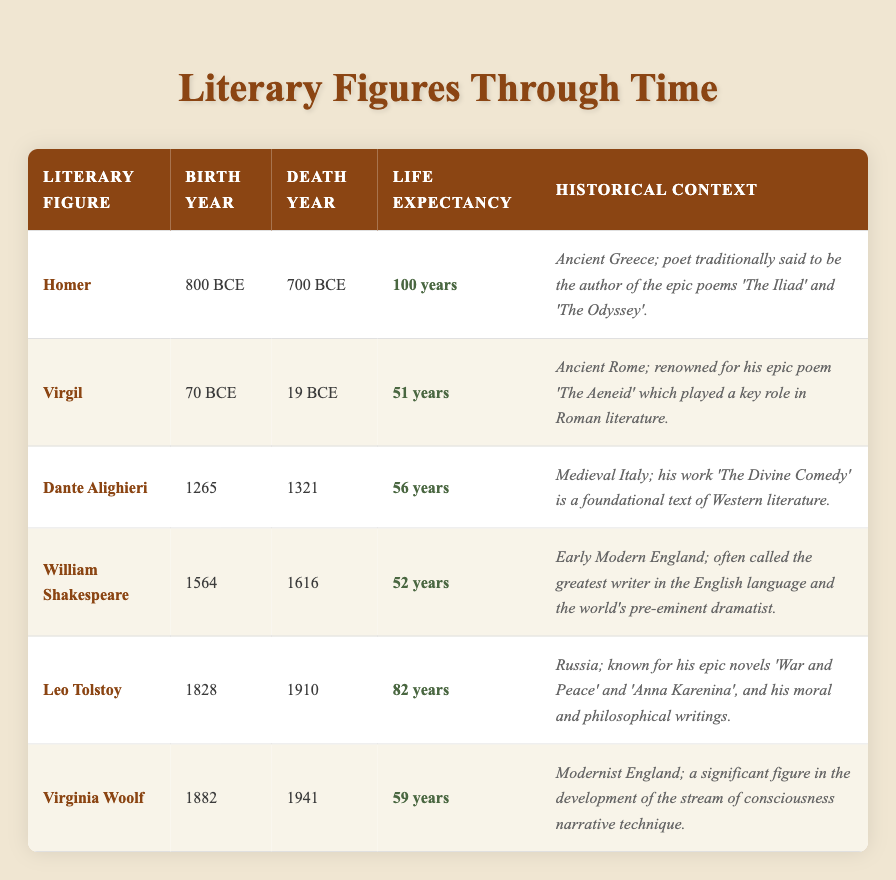What is the life expectancy of Leo Tolstoy? From the table, the life expectancy of Leo Tolstoy is clearly listed as 82 years.
Answer: 82 years Who lived the longest among these literary figures? By comparing the life expectancies, Leo Tolstoy has the highest life expectancy at 82 years, making him the longest-living literary figure in the table.
Answer: Leo Tolstoy How many years did William Shakespeare live? According to the table, William Shakespeare's life expectancy is recorded as 52 years.
Answer: 52 years Is it true that Virginia Woolf lived longer than Dante Alighieri? By examining the life expectancies in the table, Virginia Woolf lived for 59 years, while Dante Alighieri lived for 56 years, which confirms that Woolf lived longer.
Answer: Yes What is the average life expectancy of the literary figures listed? To find the average life expectancy, sum the individual life expectancies: (100 + 51 + 56 + 52 + 82 + 59) = 400. Then, divide by the total number of figures, which is 6. Thus, the average life expectancy is 400 / 6 = approximately 66.67 years.
Answer: 66.67 years Which historical context corresponds to the author of 'The Aeneid'? From the table, Virgil, known for 'The Aeneid', is categorized under Ancient Rome, making this context relevant to him.
Answer: Ancient Rome What was the life expectancy difference between Homer and Virgil? Homer had a life expectancy of 100 years, while Virgil had a life expectancy of 51 years. The difference is calculated as 100 - 51 = 49 years.
Answer: 49 years How many literary figures were born before the year 1000? By checking the birth years: Homer (-800), Virgil (70), Dante (1265), Shakespeare (1564), Tolstoy (1828), and Woolf (1882). Thus, only Homer, Virgil, and Dante were born before the year 1000, resulting in a total of 3 literary figures.
Answer: 3 literary figures 